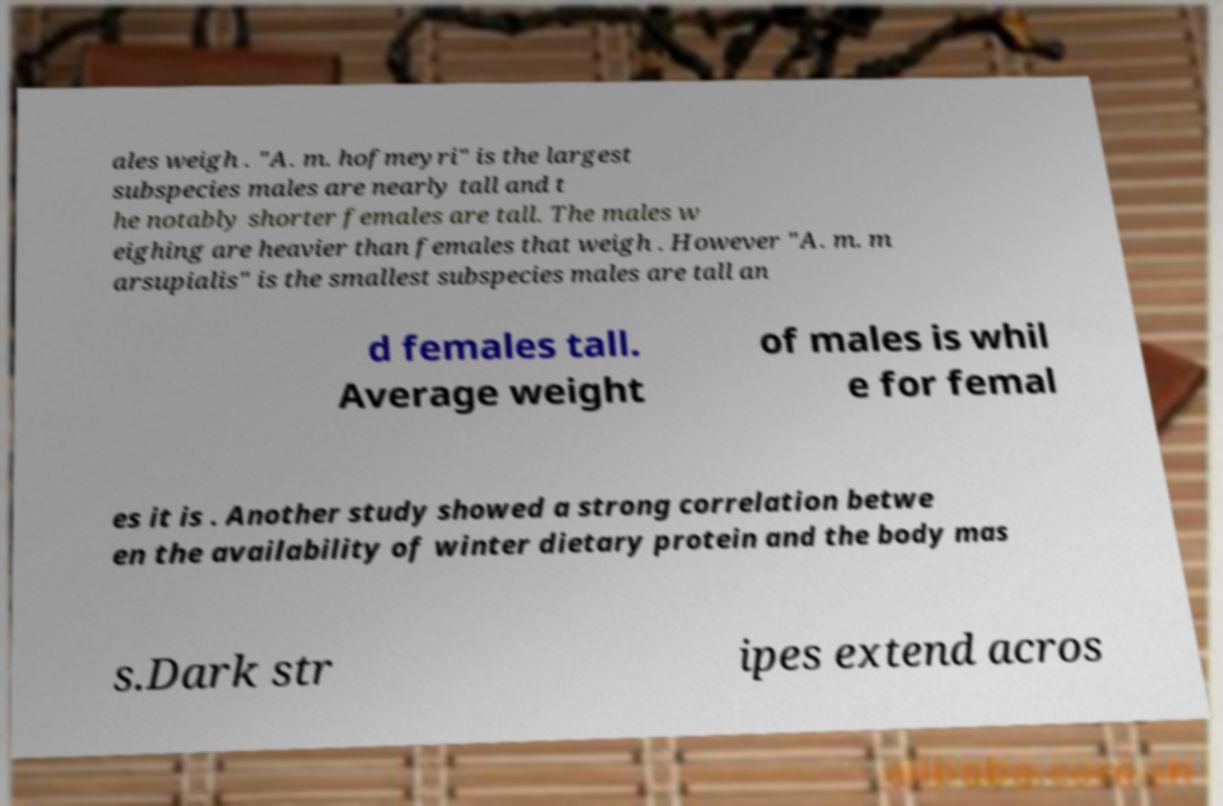Could you assist in decoding the text presented in this image and type it out clearly? ales weigh . "A. m. hofmeyri" is the largest subspecies males are nearly tall and t he notably shorter females are tall. The males w eighing are heavier than females that weigh . However "A. m. m arsupialis" is the smallest subspecies males are tall an d females tall. Average weight of males is whil e for femal es it is . Another study showed a strong correlation betwe en the availability of winter dietary protein and the body mas s.Dark str ipes extend acros 